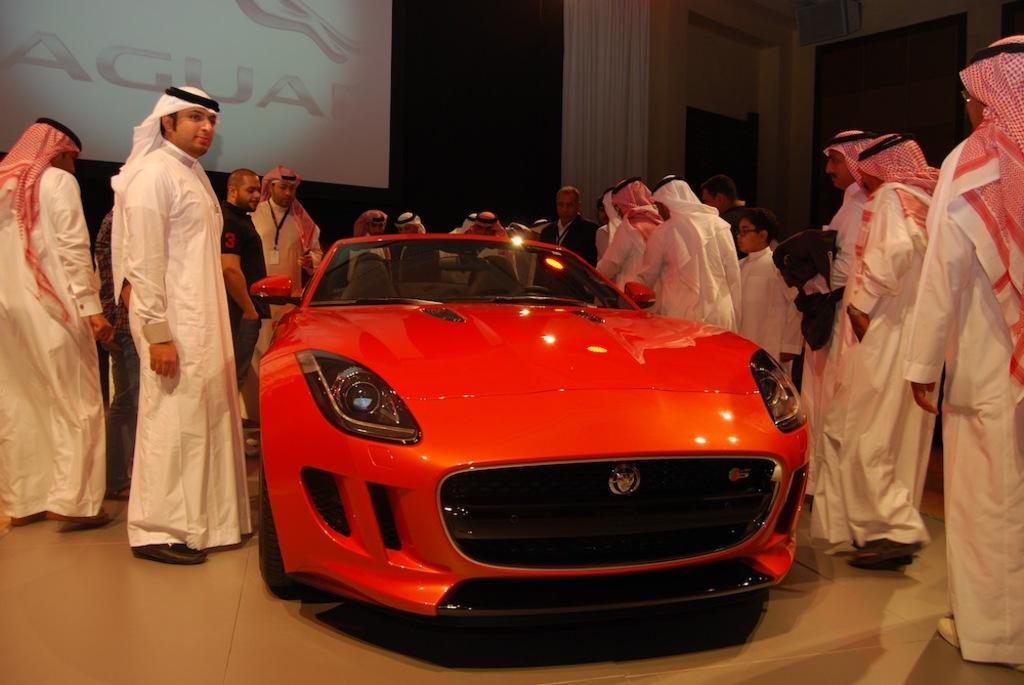What is the main subject of the picture? The main subject of the picture is a vehicle. What else can be seen in the picture besides the vehicle? There is a group of people standing in the picture. What is visible in the background of the picture? There appears to be a board or a screen in the background of the picture. What type of skirt is being worn by the vehicle in the image? There is no skirt present in the image, as the main subject is a vehicle, not a person. 